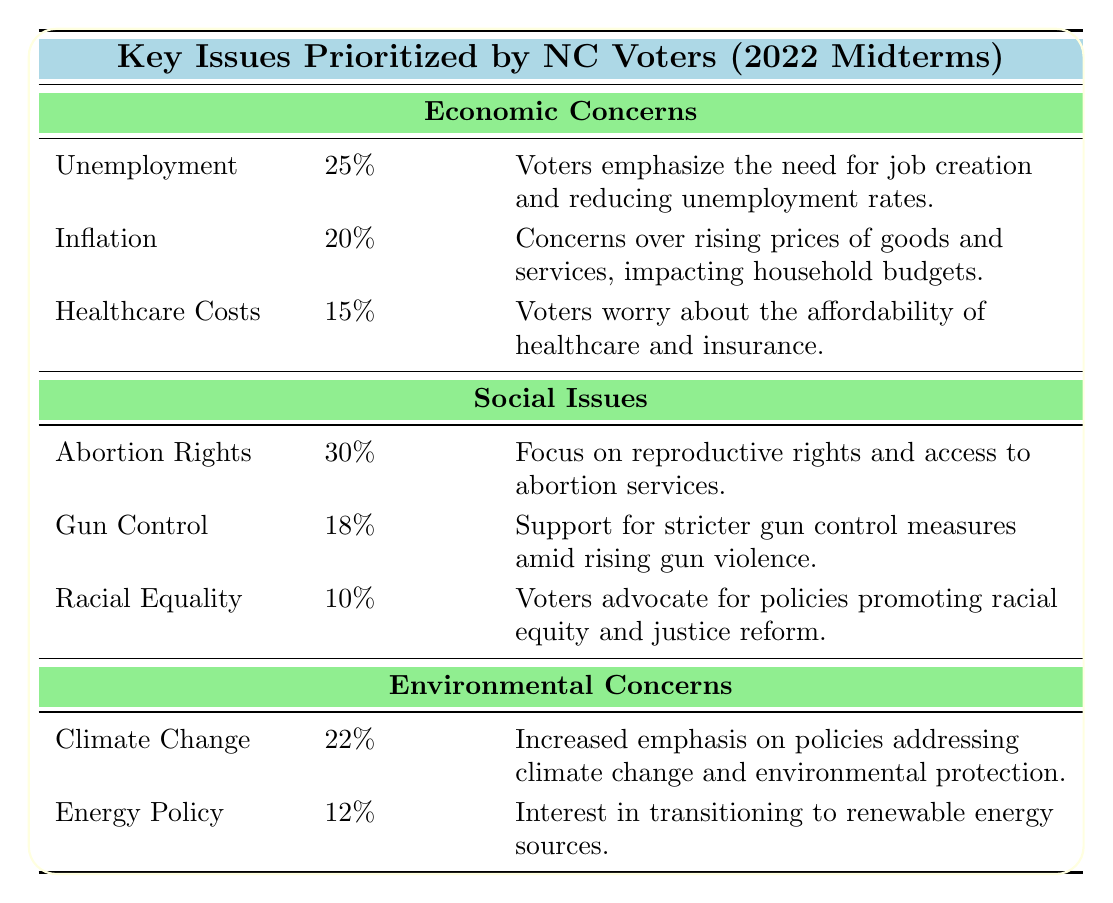What is the percentage of voters concerned about unemployment? The table explicitly states that the percentage of voters emphasizing the need for job creation and reducing unemployment rates is 25%.
Answer: 25% Which social issue has the highest percentage among voters? By examining the social issues listed, abortion rights have the highest percentage of 30%, indicating it is the top concern among voters.
Answer: 30% What are the total percentages for economic concerns? To find the total, sum the percentages of each economic concern: 25 (Unemployment) + 20 (Inflation) + 15 (Healthcare Costs) = 60%.
Answer: 60% Is the concern for racial equality higher than the concern for energy policy? The table shows that racial equality has a concern percentage of 10%, while energy policy's concern percentage is 12%. Since 10% is less than 12%, the statement is false.
Answer: No If you average the top two social issues, what is the average percentage? The top two social issues are abortion rights at 30% and gun control at 18%. The average is calculated as (30 + 18) / 2 = 24%.
Answer: 24% What percentage of voters are concerned about healthcare costs? The table clearly indicates that 15% of voters are worried about the affordability of healthcare and insurance.
Answer: 15% Which environmental concern has a higher percentage, climate change or energy policy? The table states that climate change has a percentage of 22% and energy policy has 12%. Since 22% is greater than 12%, climate change has the higher percentage.
Answer: Climate change Calculate the difference in percentage between the highest social issue and the lowest economic issue. The highest social issue is abortion rights at 30%, while the lowest economic issue is healthcare costs at 15%. The difference is calculated as 30% - 15% = 15%.
Answer: 15% 